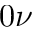<formula> <loc_0><loc_0><loc_500><loc_500>0 \nu</formula> 